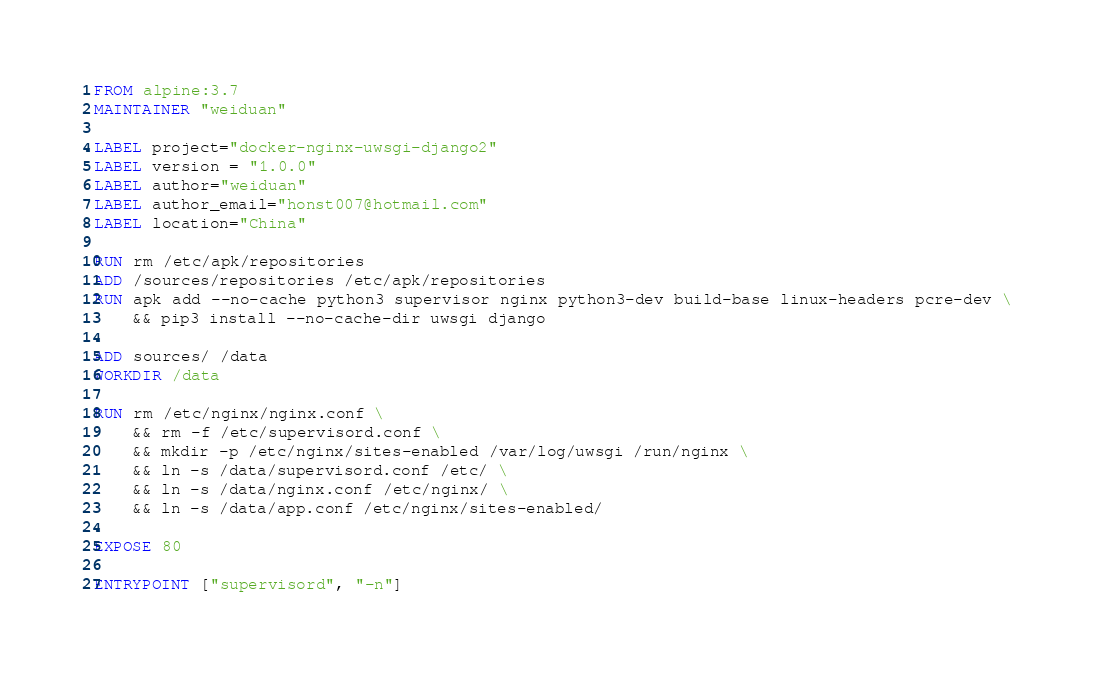Convert code to text. <code><loc_0><loc_0><loc_500><loc_500><_Dockerfile_>FROM alpine:3.7
MAINTAINER "weiduan"

LABEL project="docker-nginx-uwsgi-django2"
LABEL version = "1.0.0"
LABEL author="weiduan"
LABEL author_email="honst007@hotmail.com"
LABEL location="China"

RUN rm /etc/apk/repositories
ADD /sources/repositories /etc/apk/repositories
RUN apk add --no-cache python3 supervisor nginx python3-dev build-base linux-headers pcre-dev \
    && pip3 install --no-cache-dir uwsgi django

ADD sources/ /data
WORKDIR /data

RUN rm /etc/nginx/nginx.conf \
    && rm -f /etc/supervisord.conf \
    && mkdir -p /etc/nginx/sites-enabled /var/log/uwsgi /run/nginx \
    && ln -s /data/supervisord.conf /etc/ \
    && ln -s /data/nginx.conf /etc/nginx/ \
    && ln -s /data/app.conf /etc/nginx/sites-enabled/

EXPOSE 80

ENTRYPOINT ["supervisord", "-n"]
</code> 